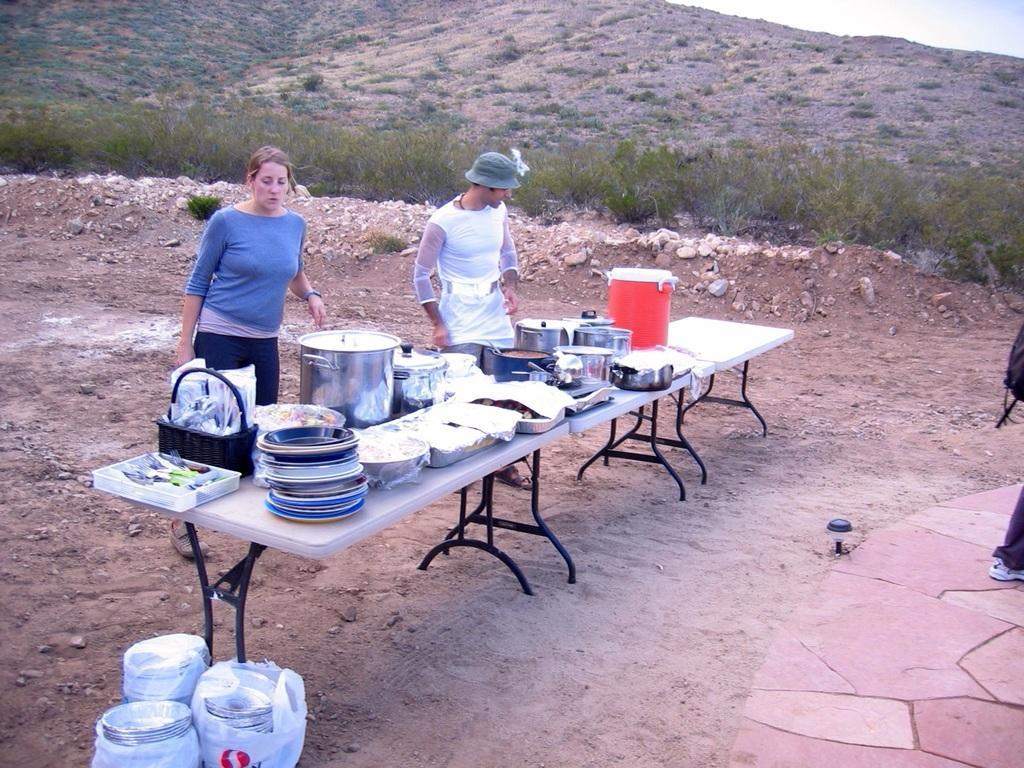Can you describe this image briefly? It is a hill station there are some cooking utensils on the table and there are two people beside the table a woman and a man both are looking at the table, in the background there is a grass, stones, sand and hills and sky. 